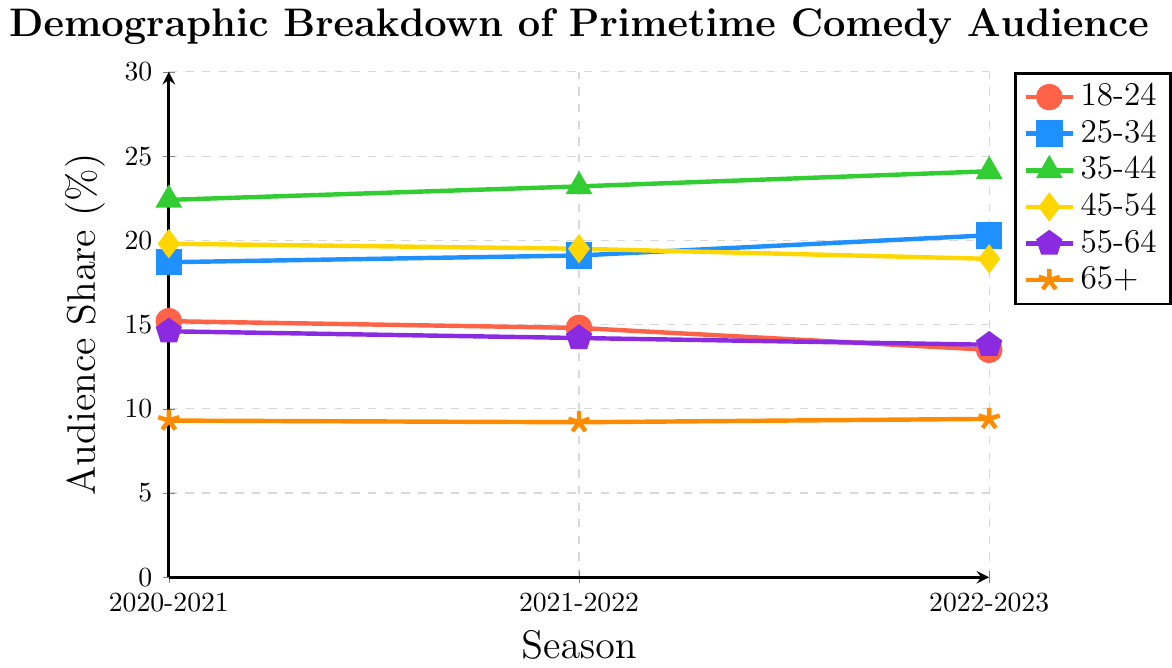What's the trend for the audience share of the 18-24 age group over the last three seasons? The 18-24 age group has shown a decreasing trend in audience share over the last three seasons. Specifically, the audience share dropped from 15.2% in 2020-2021 to 14.8% in 2021-2022, and further to 13.5% in 2022-2023.
Answer: Decreasing Which age group has the highest audience share in the 2022-2023 season? By looking at the y-values of the different lines for the 2022-2023 season, the 35-44 age group has the highest audience share with approximately 24.1%.
Answer: 35-44 What is the difference in audience share between the 25-34 and 45-54 age groups in the 2022-2023 season? In the 2022-2023 season, the audience share for the 25-34 age group is 20.3%, and for the 45-54 age group, it is 18.9%. The difference is calculated as 20.3% - 18.9% = 1.4%.
Answer: 1.4% Which age group showed an increase in audience share every season over the last three seasons? By examining the trend for each age group, only the 25-34 and 35-44 age groups have shown consistent increases over all three seasons.
Answer: 25-34, 35-44 Which age group’s audience share remained relatively stable over the three seasons compared to others? The 65+ age group's audience share remained relatively stable with minor fluctuations: 9.3% in 2020-2021, 9.2% in 2021-2022, and 9.4% in 2022-2023.
Answer: 65+ How much did the audience share for the 55-64 age group decrease from 2020-2021 to 2022-2023? The audience share for the 55-64 age group decreased from 14.6% in 2020-2021 to 13.8% in 2022-2023. The difference is 14.6% - 13.8% = 0.8%.
Answer: 0.8% Compare the audience share changes of the 18-24 and 45-54 age groups from 2020-2021 to 2022-2023. Which age group had a larger change? The 18-24 age group decreased from 15.2% to 13.5%, a change of 15.2% - 13.5% = 1.7%. The 45-54 age group decreased from 19.8% to 18.9%, a change of 19.8% - 18.9% = 0.9%. The 18-24 age group had a larger change.
Answer: 18-24 Identify the color associated with the 35-44 age group and describe its line markings. The 35-44 age group is represented in green with triangle markers along the line plot.
Answer: Green with triangles 